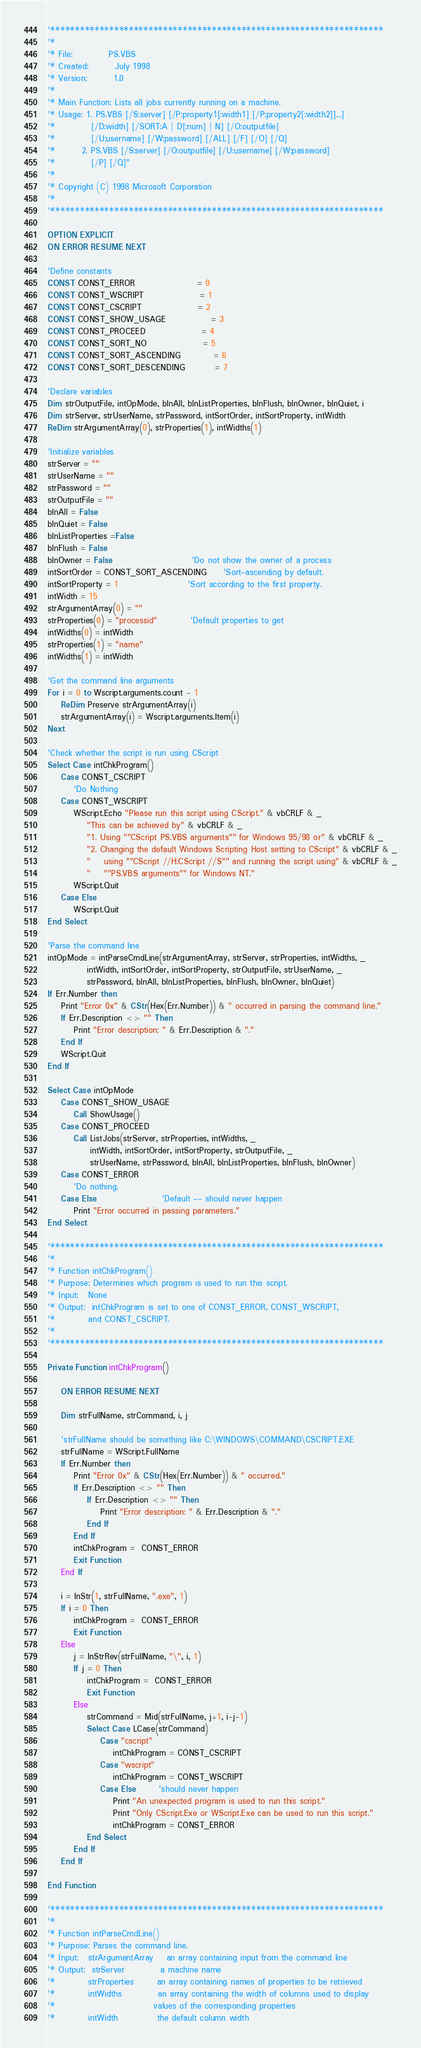<code> <loc_0><loc_0><loc_500><loc_500><_VisualBasic_>
'********************************************************************
'*
'* File:           PS.VBS
'* Created:        July 1998
'* Version:        1.0
'*
'* Main Function: Lists all jobs currently running on a machine.
'* Usage: 1. PS.VBS [/S:server] [/P:property1[:width1] [/P:property2[:width2]]...]
'*           [/D:width] [/SORT:A | D[:num] | N] [/O:outputfile]
'*           [/U:username] [/W:password] [/ALL] [/F] [/O] [/Q]
'*        2. PS.VBS [/S:server] [/O:outputfile] [/U:username] [/W:password]
'*           [/P] [/Q]"
'*
'* Copyright (C) 1998 Microsoft Corporation
'*
'********************************************************************

OPTION EXPLICIT
ON ERROR RESUME NEXT

'Define constants
CONST CONST_ERROR                   = 0
CONST CONST_WSCRIPT                 = 1
CONST CONST_CSCRIPT                 = 2
CONST CONST_SHOW_USAGE              = 3
CONST CONST_PROCEED                 = 4
CONST CONST_SORT_NO                 = 5
CONST CONST_SORT_ASCENDING          = 6
CONST CONST_SORT_DESCENDING         = 7

'Declare variables
Dim strOutputFile, intOpMode, blnAll, blnListProperties, blnFlush, blnOwner, blnQuiet, i
Dim strServer, strUserName, strPassword, intSortOrder, intSortProperty, intWidth
ReDim strArgumentArray(0), strProperties(1), intWidths(1)

'Initialize variables
strServer = ""
strUserName = ""
strPassword = ""
strOutputFile = ""
blnAll = False
blnQuiet = False
blnListProperties =False
blnFlush = False
blnOwner = False                        'Do not show the owner of a process
intSortOrder = CONST_SORT_ASCENDING     'Sort-ascending by default.
intSortProperty = 1                     'Sort according to the first property.
intWidth = 15
strArgumentArray(0) = ""
strProperties(0) = "processid"          'Default properties to get
intWidths(0) = intWidth
strProperties(1) = "name"
intWidths(1) = intWidth

'Get the command line arguments
For i = 0 to Wscript.arguments.count - 1
    ReDim Preserve strArgumentArray(i)
    strArgumentArray(i) = Wscript.arguments.Item(i)
Next

'Check whether the script is run using CScript
Select Case intChkProgram()
    Case CONST_CSCRIPT
        'Do Nothing
    Case CONST_WSCRIPT
        WScript.Echo "Please run this script using CScript." & vbCRLF & _
            "This can be achieved by" & vbCRLF & _
            "1. Using ""CScript PS.VBS arguments"" for Windows 95/98 or" & vbCRLF & _
            "2. Changing the default Windows Scripting Host setting to CScript" & vbCRLF & _
            "    using ""CScript //H:CScript //S"" and running the script using" & vbCRLF & _
            "    ""PS.VBS arguments"" for Windows NT."
        WScript.Quit
    Case Else
        WScript.Quit
End Select

'Parse the command line
intOpMode = intParseCmdLine(strArgumentArray, strServer, strProperties, intWidths, _
            intWidth, intSortOrder, intSortProperty, strOutputFile, strUserName, _
            strPassword, blnAll, blnListProperties, blnFlush, blnOwner, blnQuiet)
If Err.Number then
    Print "Error 0x" & CStr(Hex(Err.Number)) & " occurred in parsing the command line."
    If Err.Description <> "" Then
        Print "Error description: " & Err.Description & "."
    End If
    WScript.Quit
End If

Select Case intOpMode
    Case CONST_SHOW_USAGE
        Call ShowUsage()
    Case CONST_PROCEED
        Call ListJobs(strServer, strProperties, intWidths, _
             intWidth, intSortOrder, intSortProperty, strOutputFile, _
             strUserName, strPassword, blnAll, blnListProperties, blnFlush, blnOwner)
    Case CONST_ERROR
        'Do nothing.
    Case Else                    'Default -- should never happen
        Print "Error occurred in passing parameters."
End Select

'********************************************************************
'*
'* Function intChkProgram()
'* Purpose: Determines which program is used to run this script.
'* Input:   None
'* Output:  intChkProgram is set to one of CONST_ERROR, CONST_WSCRIPT,
'*          and CONST_CSCRIPT.
'*
'********************************************************************

Private Function intChkProgram()

    ON ERROR RESUME NEXT

    Dim strFullName, strCommand, i, j

    'strFullName should be something like C:\WINDOWS\COMMAND\CSCRIPT.EXE
    strFullName = WScript.FullName
    If Err.Number then
        Print "Error 0x" & CStr(Hex(Err.Number)) & " occurred."
        If Err.Description <> "" Then
            If Err.Description <> "" Then
                Print "Error description: " & Err.Description & "."
            End If
        End If
        intChkProgram =  CONST_ERROR
        Exit Function
    End If

    i = InStr(1, strFullName, ".exe", 1)
    If i = 0 Then
        intChkProgram =  CONST_ERROR
        Exit Function
    Else
        j = InStrRev(strFullName, "\", i, 1)
        If j = 0 Then
            intChkProgram =  CONST_ERROR
            Exit Function
        Else
            strCommand = Mid(strFullName, j+1, i-j-1)
            Select Case LCase(strCommand)
                Case "cscript"
                    intChkProgram = CONST_CSCRIPT
                Case "wscript"
                    intChkProgram = CONST_WSCRIPT
                Case Else       'should never happen
                    Print "An unexpected program is used to run this script."
                    Print "Only CScript.Exe or WScript.Exe can be used to run this script."
                    intChkProgram = CONST_ERROR
            End Select
        End If
    End If

End Function

'********************************************************************
'*
'* Function intParseCmdLine()
'* Purpose: Parses the command line.
'* Input:   strArgumentArray    an array containing input from the command line
'* Output:  strServer           a machine name
'*          strProperties       an array containing names of properties to be retrieved
'*          intWidths           an array containing the width of columns used to display
'*                              values of the corresponding properties
'*          intWidth            the default column width</code> 